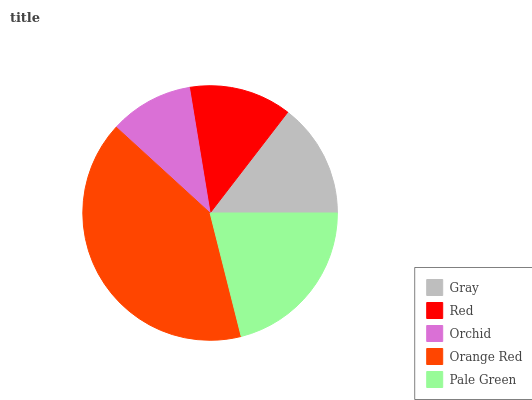Is Orchid the minimum?
Answer yes or no. Yes. Is Orange Red the maximum?
Answer yes or no. Yes. Is Red the minimum?
Answer yes or no. No. Is Red the maximum?
Answer yes or no. No. Is Gray greater than Red?
Answer yes or no. Yes. Is Red less than Gray?
Answer yes or no. Yes. Is Red greater than Gray?
Answer yes or no. No. Is Gray less than Red?
Answer yes or no. No. Is Gray the high median?
Answer yes or no. Yes. Is Gray the low median?
Answer yes or no. Yes. Is Orange Red the high median?
Answer yes or no. No. Is Pale Green the low median?
Answer yes or no. No. 